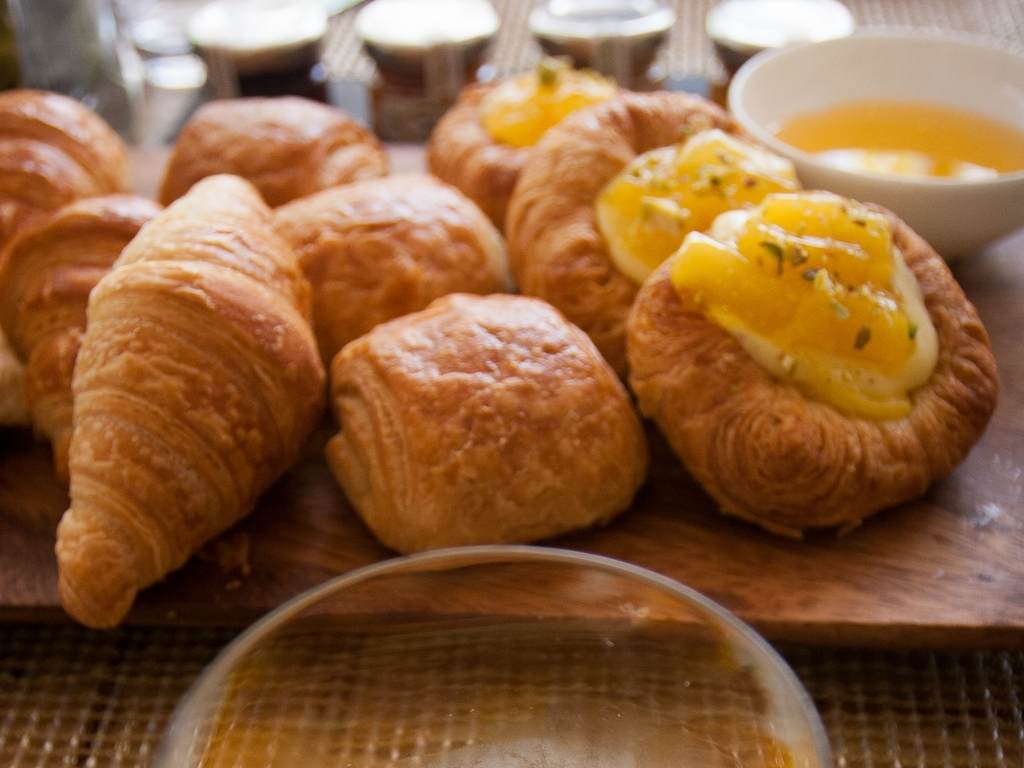Can you tell me more about what's in this picture? Certainly! This image features an assortment of freshly baked croissants, some plain and others filled with a yellow cream topping, possibly a lemon curd or custard. There's also a bowl of this yellow cream beside the croissants, suggesting it's available for adding extra filling or topping. The setting looks cozy, perhaps hinting at a relaxed breakfast or brunch. 